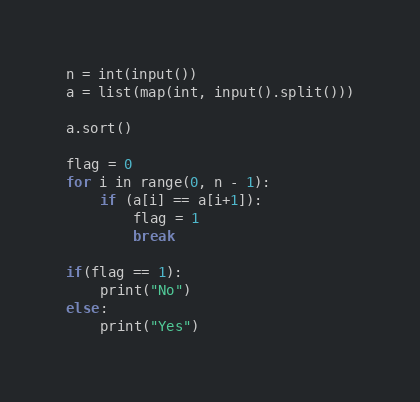<code> <loc_0><loc_0><loc_500><loc_500><_Python_>n = int(input())
a = list(map(int, input().split()))

a.sort()

flag = 0
for i in range(0, n - 1):
    if (a[i] == a[i+1]):
        flag = 1
        break

if(flag == 1):
    print("No")
else:
    print("Yes")
</code> 